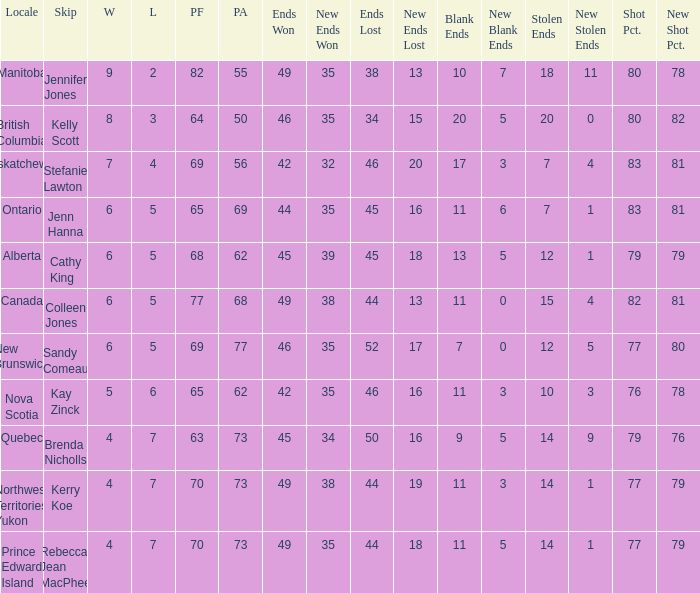What is the PA when the PF is 77? 68.0. 